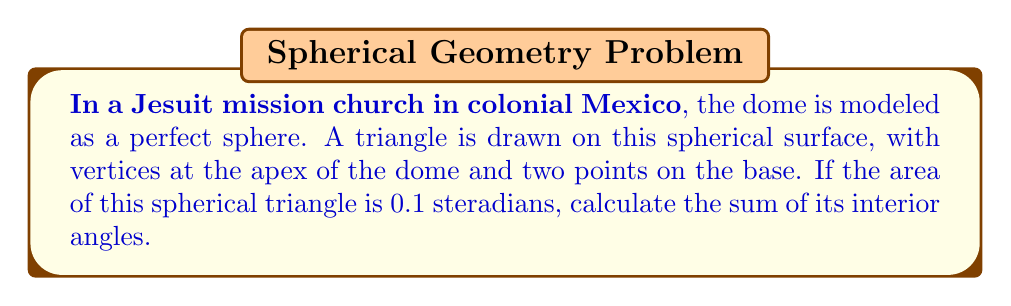Can you solve this math problem? Let's approach this step-by-step:

1) In spherical geometry, the sum of the angles in a triangle is not always 180°. Instead, it depends on the area of the triangle.

2) The relationship between the area of a spherical triangle and the sum of its angles is given by the Girard's theorem:

   $$A = (α + β + γ - π)R^2$$

   Where A is the area, α, β, and γ are the angles of the triangle, and R is the radius of the sphere.

3) We are given that the area is 0.1 steradians. In spherical geometry, area is often measured in steradians, which are dimensionless. This means that R = 1 in our equation.

4) Substituting these values into Girard's theorem:

   $$0.1 = (α + β + γ - π)$$

5) Solving for the sum of the angles:

   $$α + β + γ = 0.1 + π$$

6) Convert π to radians:

   $$α + β + γ = 0.1 + 3.14159...$$

7) Simplifying:

   $$α + β + γ ≈ 3.24159... \text{ radians}$$

8) To convert to degrees, multiply by (180/π):

   $$α + β + γ ≈ 3.24159... * (180/π) ≈ 185.7°$$
Answer: $185.7°$ 